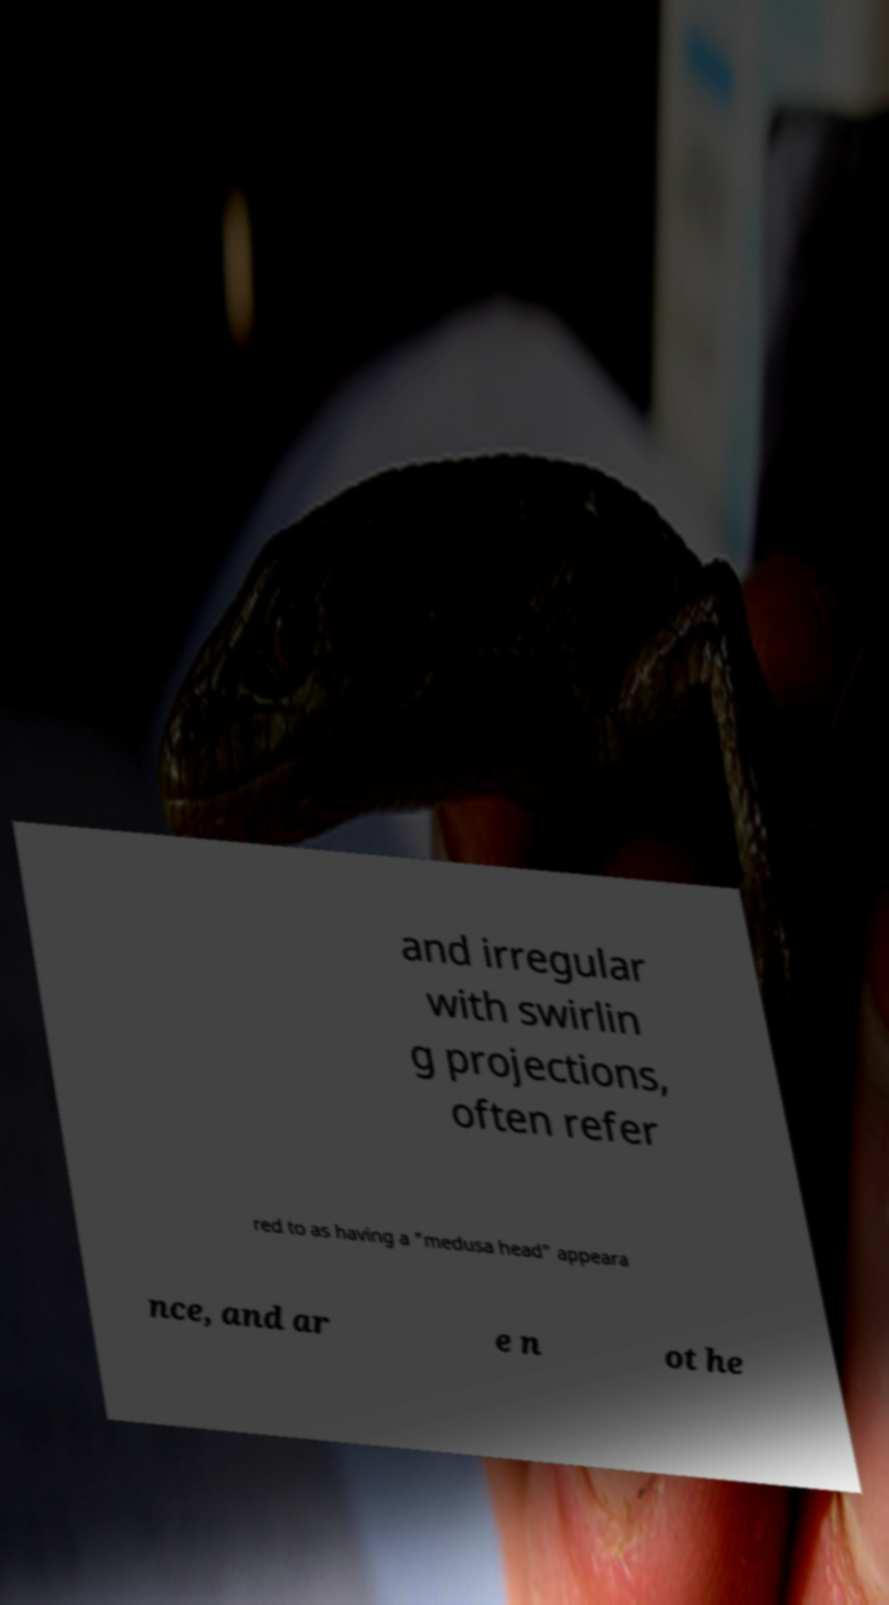I need the written content from this picture converted into text. Can you do that? and irregular with swirlin g projections, often refer red to as having a "medusa head" appeara nce, and ar e n ot he 